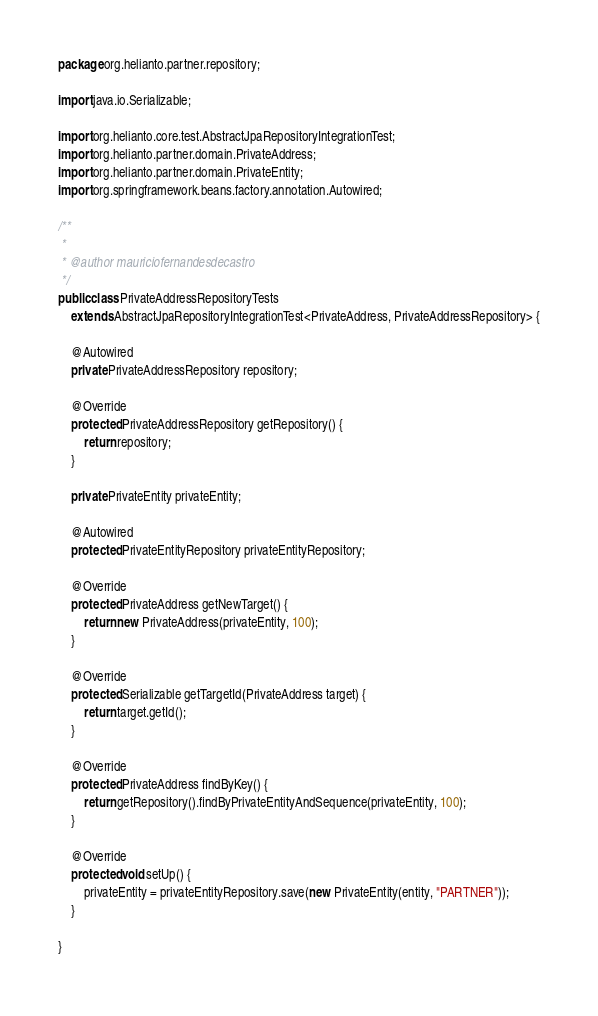Convert code to text. <code><loc_0><loc_0><loc_500><loc_500><_Java_>package org.helianto.partner.repository;

import java.io.Serializable;

import org.helianto.core.test.AbstractJpaRepositoryIntegrationTest;
import org.helianto.partner.domain.PrivateAddress;
import org.helianto.partner.domain.PrivateEntity;
import org.springframework.beans.factory.annotation.Autowired;

/**
 * 
 * @author mauriciofernandesdecastro
 */
public class PrivateAddressRepositoryTests 
	extends AbstractJpaRepositoryIntegrationTest<PrivateAddress, PrivateAddressRepository> {

	@Autowired
	private PrivateAddressRepository repository;
	
	@Override
	protected PrivateAddressRepository getRepository() {
		return repository;
	}

    private PrivateEntity privateEntity;
	
	@Autowired
	protected PrivateEntityRepository privateEntityRepository;

	@Override
	protected PrivateAddress getNewTarget() {
		return new PrivateAddress(privateEntity, 100);
	}

	@Override
	protected Serializable getTargetId(PrivateAddress target) {
		return target.getId();
	}

	@Override
	protected PrivateAddress findByKey() {
		return getRepository().findByPrivateEntityAndSequence(privateEntity, 100);
	}
	
	@Override
	protected void setUp() {
		privateEntity = privateEntityRepository.save(new PrivateEntity(entity, "PARTNER"));
	}

}
</code> 